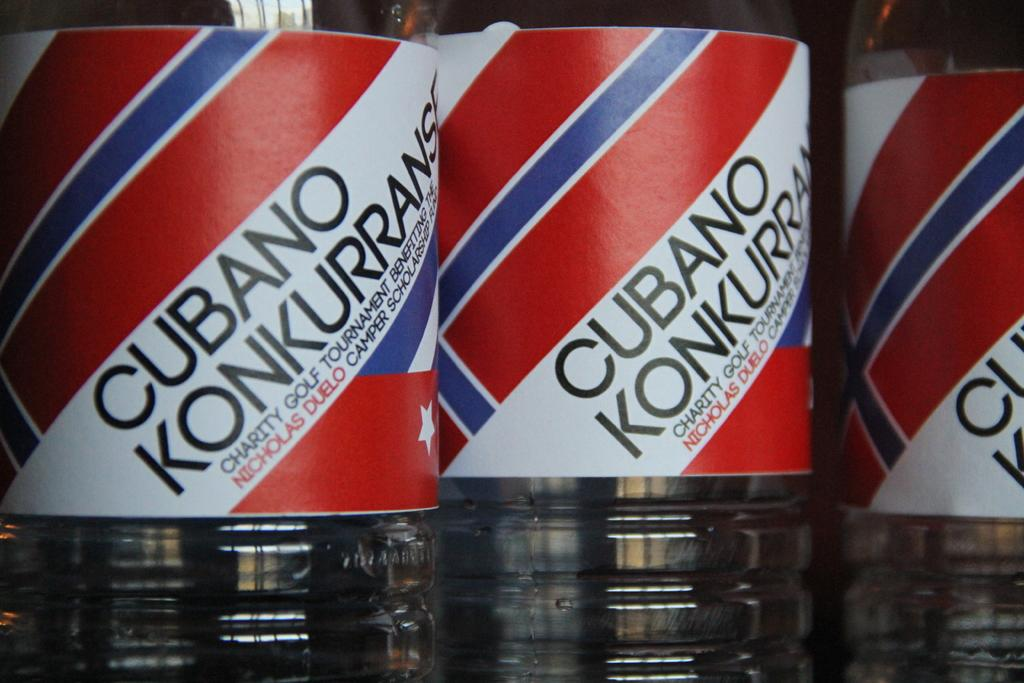<image>
Provide a brief description of the given image. a drink that has the word cubano on it 